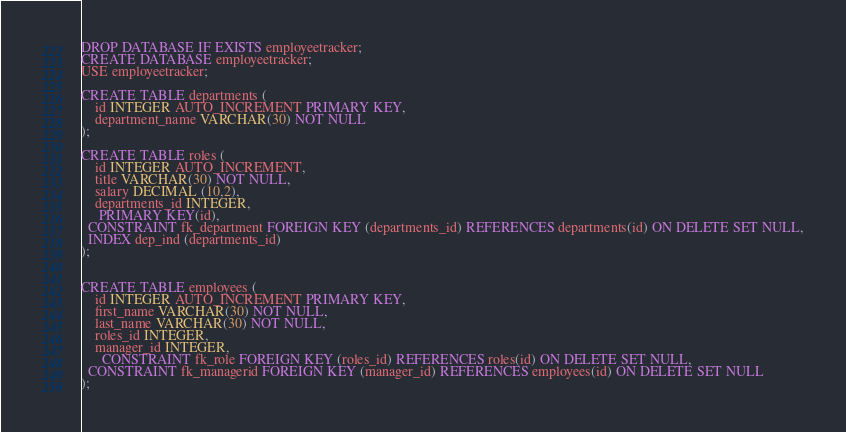<code> <loc_0><loc_0><loc_500><loc_500><_SQL_>DROP DATABASE IF EXISTS employeetracker;
CREATE DATABASE employeetracker;
USE employeetracker;

CREATE TABLE departments (
    id INTEGER AUTO_INCREMENT PRIMARY KEY,
    department_name VARCHAR(30) NOT NULL
);

CREATE TABLE roles (
    id INTEGER AUTO_INCREMENT,
    title VARCHAR(30) NOT NULL,
    salary DECIMAL (10,2),
    departments_id INTEGER,
     PRIMARY KEY(id),
  CONSTRAINT fk_department FOREIGN KEY (departments_id) REFERENCES departments(id) ON DELETE SET NULL,
  INDEX dep_ind (departments_id)
);


CREATE TABLE employees (
    id INTEGER AUTO_INCREMENT PRIMARY KEY,
    first_name VARCHAR(30) NOT NULL,
    last_name VARCHAR(30) NOT NULL,
    roles_id INTEGER,
    manager_id INTEGER,
      CONSTRAINT fk_role FOREIGN KEY (roles_id) REFERENCES roles(id) ON DELETE SET NULL,
  CONSTRAINT fk_managerid FOREIGN KEY (manager_id) REFERENCES employees(id) ON DELETE SET NULL
);

</code> 